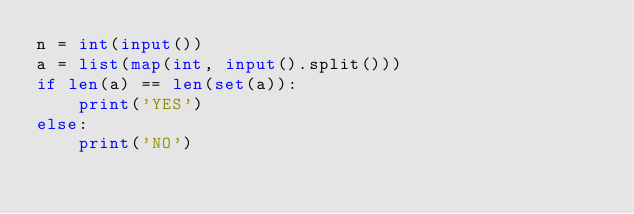<code> <loc_0><loc_0><loc_500><loc_500><_Python_>n = int(input())
a = list(map(int, input().split()))
if len(a) == len(set(a)):
    print('YES')
else:
    print('NO')</code> 